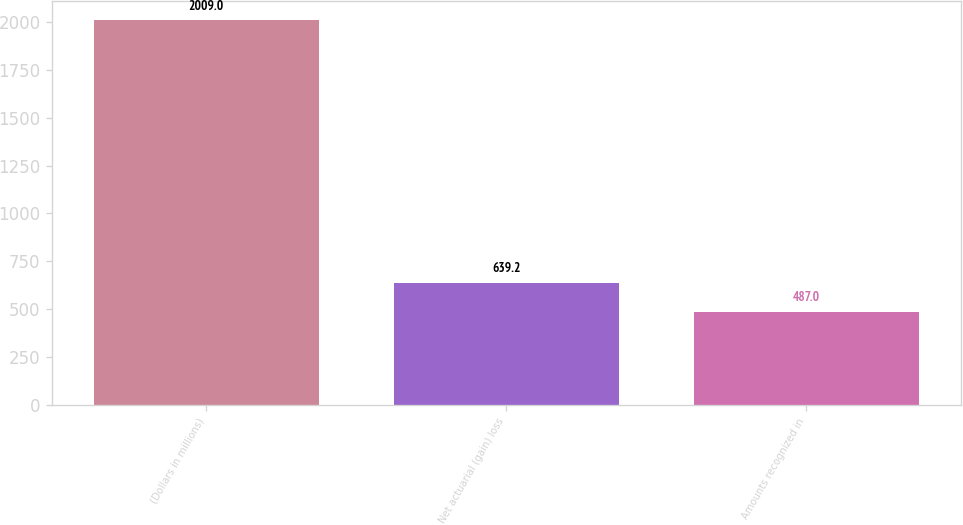<chart> <loc_0><loc_0><loc_500><loc_500><bar_chart><fcel>(Dollars in millions)<fcel>Net actuarial (gain) loss<fcel>Amounts recognized in<nl><fcel>2009<fcel>639.2<fcel>487<nl></chart> 